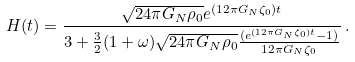Convert formula to latex. <formula><loc_0><loc_0><loc_500><loc_500>H ( t ) = \frac { \sqrt { 2 4 \pi G _ { N } \rho _ { 0 } } e ^ { ( 1 2 \pi G _ { N } \zeta _ { 0 } ) t } } { 3 + \frac { 3 } { 2 } ( 1 + \omega ) \sqrt { 2 4 \pi G _ { N } \rho _ { 0 } } \frac { ( e ^ { ( 1 2 \pi G _ { N } \zeta _ { 0 } ) t } - 1 ) } { 1 2 \pi G _ { N } \zeta _ { 0 } } } \, .</formula> 